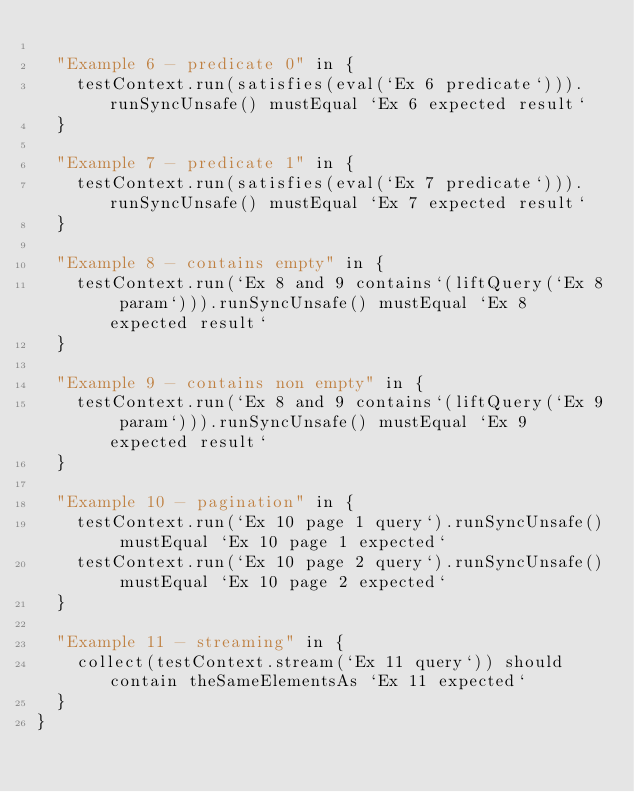Convert code to text. <code><loc_0><loc_0><loc_500><loc_500><_Scala_>
  "Example 6 - predicate 0" in {
    testContext.run(satisfies(eval(`Ex 6 predicate`))).runSyncUnsafe() mustEqual `Ex 6 expected result`
  }

  "Example 7 - predicate 1" in {
    testContext.run(satisfies(eval(`Ex 7 predicate`))).runSyncUnsafe() mustEqual `Ex 7 expected result`
  }

  "Example 8 - contains empty" in {
    testContext.run(`Ex 8 and 9 contains`(liftQuery(`Ex 8 param`))).runSyncUnsafe() mustEqual `Ex 8 expected result`
  }

  "Example 9 - contains non empty" in {
    testContext.run(`Ex 8 and 9 contains`(liftQuery(`Ex 9 param`))).runSyncUnsafe() mustEqual `Ex 9 expected result`
  }

  "Example 10 - pagination" in {
    testContext.run(`Ex 10 page 1 query`).runSyncUnsafe() mustEqual `Ex 10 page 1 expected`
    testContext.run(`Ex 10 page 2 query`).runSyncUnsafe() mustEqual `Ex 10 page 2 expected`
  }

  "Example 11 - streaming" in {
    collect(testContext.stream(`Ex 11 query`)) should contain theSameElementsAs `Ex 11 expected`
  }
}
</code> 